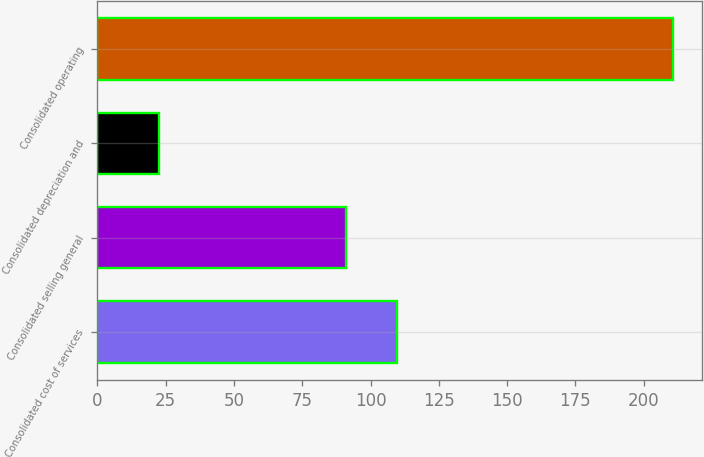<chart> <loc_0><loc_0><loc_500><loc_500><bar_chart><fcel>Consolidated cost of services<fcel>Consolidated selling general<fcel>Consolidated depreciation and<fcel>Consolidated operating<nl><fcel>109.83<fcel>91<fcel>22.4<fcel>210.7<nl></chart> 